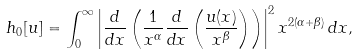<formula> <loc_0><loc_0><loc_500><loc_500>h _ { 0 } [ u ] = \int _ { 0 } ^ { \infty } \left | \frac { d } { d x } \left ( \frac { 1 } { x ^ { \alpha } } \frac { d } { d x } \left ( \frac { u ( x ) } { x ^ { \beta } } \right ) \right ) \right | ^ { 2 } x ^ { 2 ( \alpha + \beta ) } \, d x ,</formula> 